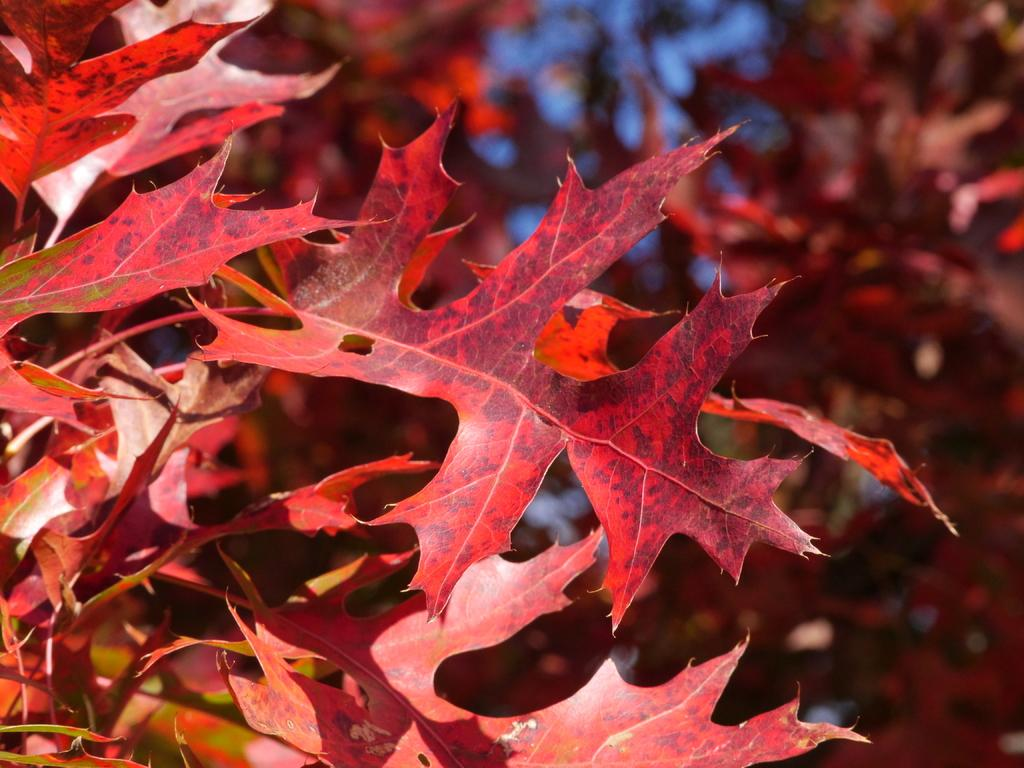What is the main subject of the picture? The main subject of the picture is a tree. What is unique about the tree's appearance? The tree has leaves in red color. What type of account does the tree have in the image? There is no reference to an account in the image, as it features a tree with red leaves. 